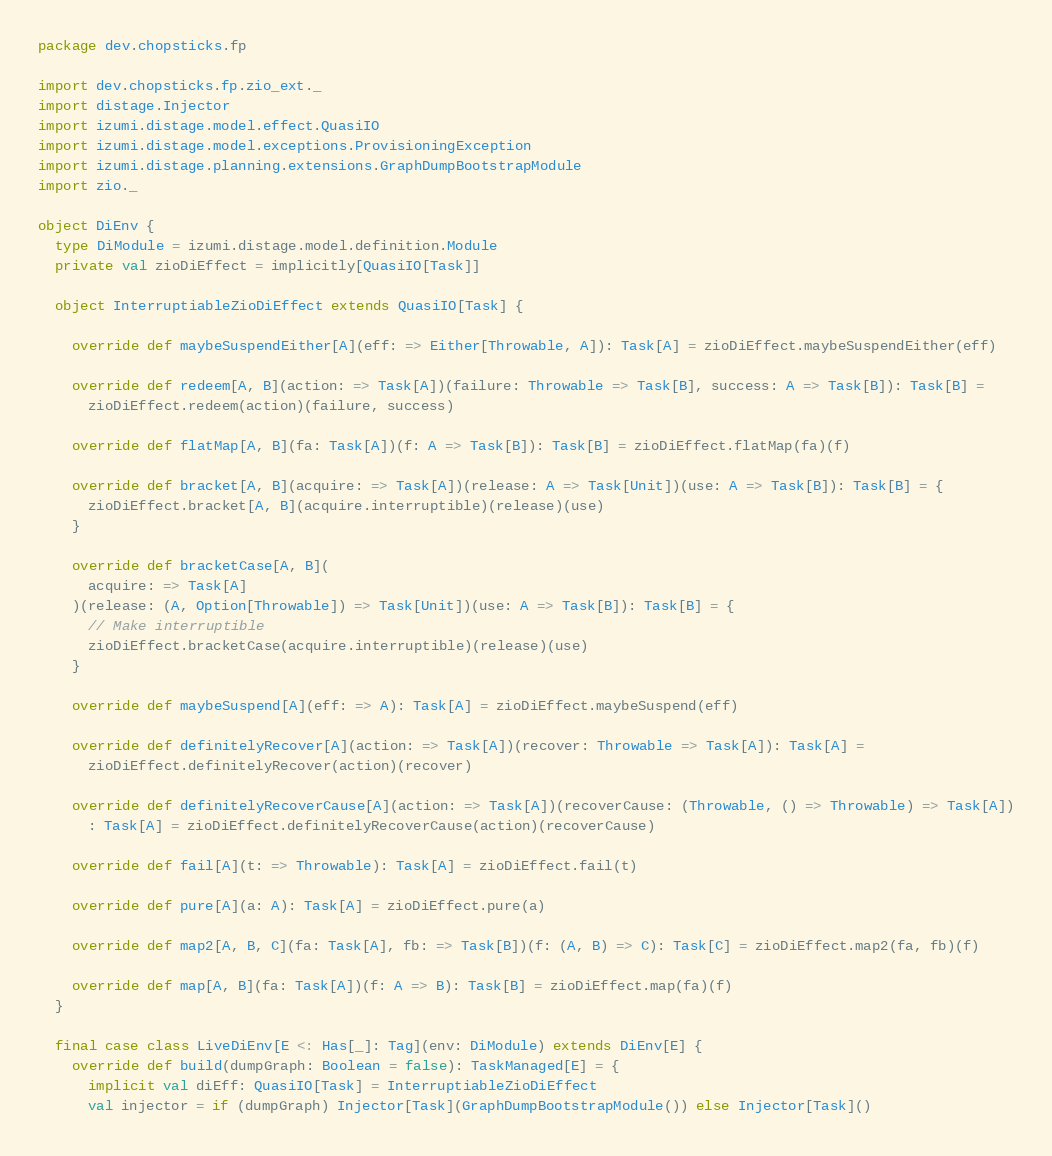<code> <loc_0><loc_0><loc_500><loc_500><_Scala_>package dev.chopsticks.fp

import dev.chopsticks.fp.zio_ext._
import distage.Injector
import izumi.distage.model.effect.QuasiIO
import izumi.distage.model.exceptions.ProvisioningException
import izumi.distage.planning.extensions.GraphDumpBootstrapModule
import zio._

object DiEnv {
  type DiModule = izumi.distage.model.definition.Module
  private val zioDiEffect = implicitly[QuasiIO[Task]]

  object InterruptiableZioDiEffect extends QuasiIO[Task] {

    override def maybeSuspendEither[A](eff: => Either[Throwable, A]): Task[A] = zioDiEffect.maybeSuspendEither(eff)

    override def redeem[A, B](action: => Task[A])(failure: Throwable => Task[B], success: A => Task[B]): Task[B] =
      zioDiEffect.redeem(action)(failure, success)

    override def flatMap[A, B](fa: Task[A])(f: A => Task[B]): Task[B] = zioDiEffect.flatMap(fa)(f)

    override def bracket[A, B](acquire: => Task[A])(release: A => Task[Unit])(use: A => Task[B]): Task[B] = {
      zioDiEffect.bracket[A, B](acquire.interruptible)(release)(use)
    }

    override def bracketCase[A, B](
      acquire: => Task[A]
    )(release: (A, Option[Throwable]) => Task[Unit])(use: A => Task[B]): Task[B] = {
      // Make interruptible
      zioDiEffect.bracketCase(acquire.interruptible)(release)(use)
    }

    override def maybeSuspend[A](eff: => A): Task[A] = zioDiEffect.maybeSuspend(eff)

    override def definitelyRecover[A](action: => Task[A])(recover: Throwable => Task[A]): Task[A] =
      zioDiEffect.definitelyRecover(action)(recover)

    override def definitelyRecoverCause[A](action: => Task[A])(recoverCause: (Throwable, () => Throwable) => Task[A])
      : Task[A] = zioDiEffect.definitelyRecoverCause(action)(recoverCause)

    override def fail[A](t: => Throwable): Task[A] = zioDiEffect.fail(t)

    override def pure[A](a: A): Task[A] = zioDiEffect.pure(a)

    override def map2[A, B, C](fa: Task[A], fb: => Task[B])(f: (A, B) => C): Task[C] = zioDiEffect.map2(fa, fb)(f)

    override def map[A, B](fa: Task[A])(f: A => B): Task[B] = zioDiEffect.map(fa)(f)
  }

  final case class LiveDiEnv[E <: Has[_]: Tag](env: DiModule) extends DiEnv[E] {
    override def build(dumpGraph: Boolean = false): TaskManaged[E] = {
      implicit val diEff: QuasiIO[Task] = InterruptiableZioDiEffect
      val injector = if (dumpGraph) Injector[Task](GraphDumpBootstrapModule()) else Injector[Task]()</code> 